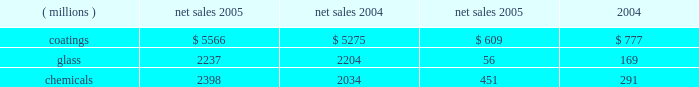Management 2019s discussion and analysis action antitrust legal settlement .
Net income for 2005 and 2004 included an aftertax charge of $ 13 million , or 8 cents a share , and $ 19 million , or 11 cents a share , respectively , to reflect the net increase in the current value of the company 2019s obligation under the ppg settlement arrangement relating to asbestos claims .
Results of business segments net sales operating income ( millions ) 2005 2004 2005 2004 .
Coatings sales increased $ 291 million or 5% ( 5 % ) in 2005 .
Sales increased 3% ( 3 % ) due to higher selling prices across all businesses except automotive ; 1% ( 1 % ) due to improved volumes as increases in our aerospace , architectural and original equipment automotive businesses offset volume declines in automotive refinish and industrial coatings ; and 1% ( 1 % ) due to the positive effects of foreign currency translation .
Operating income decreased $ 168 million in 2005 .
The adverse impact of inflation totaled $ 315 million , of which $ 245 million was attributable to higher raw material costs .
Higher year-over-year selling prices increased operating earnings by $ 169 million .
Coatings operating earnings were reduced by the $ 132 million charge for the cost of the marvin legal settlement net of insurance recoveries .
Other factors increasing coatings operating income in 2005 were the increased sales volumes described above , manufacturing efficiencies , formula cost reductions and higher other income .
Glass sales increased $ 33 million or 1% ( 1 % ) in 2005 .
Sales increased 1% ( 1 % ) due to improved volumes as increases in our automotive replacement glass , insurance and services and performance glazings ( flat glass ) businesses offset volume declines in our fiber glass and automotive original equipment glass businesses .
The positive effects of foreign currency translation were largely offset by lower selling prices primarily in our automotive replacement glass and automotive original equipment businesses .
Operating income decreased $ 113 million in 2005 .
The federal glass class action antitrust legal settlement of $ 61 million , the $ 49 million impact of rising natural gas costs and the absence of the $ 19 million gain in 2004 from the sale/ leaseback of precious metal combined to account for a reduction in operating earnings of $ 129 million .
The remaining year-over-year increase in glass operating earnings of $ 16 million resulted primarily from improved manufacturing efficiencies and lower overhead costs exceeding the adverse impact of other inflation .
Our continuing efforts in 2005 to position the fiber glass business for future growth in profitability were adversely impacted by the rise in fourth quarter natural gas prices , slightly lower year-over-year sales , lower equity earnings due to weaker pricing in the asian electronics market , and the absence of the $ 19 million gain which occurred in 2004 stemming from the sale/ leaseback of precious metals .
Despite high energy costs , we expect fiber glass earnings to improve in 2006 because of price strengthening in the asian electronics market , which began to occur in the fourth quarter of 2005 , increased cost reduction initiatives and the positive impact resulting from the start up of our new joint venture in china .
This joint venture will produce high labor content fiber glass reinforcement products and take advantage of lower labor costs , allowing us to refocus our u.s .
Production capacity on higher margin direct process products .
The 2005 operating earnings of our north american automotive oem glass business declined by $ 30 million compared with 2004 .
Significant structural changes continue to occur in the north american automotive industry , including the loss of u.s .
Market share by general motors and ford .
This has created a very challenging and competitive environment for all suppliers to the domestic oems , including our business .
About half of the decline in earnings resulted from the impact of rising natural gas costs , particularly in the fourth quarter , combined with the traditional adverse impact of year-over-year sales price reductions producing a decline in earnings that exceeded our successful efforts to reduce manufacturing costs .
The other half of the 2005 decline was due to lower sales volumes and mix and higher new program launch costs .
The challenging competitive environment and high energy prices will continue in 2006 .
Our business is working in 2006 to improve its performance through increased manufacturing efficiencies , structural cost reduction initiatives , focusing on profitable growth opportunities and improving our sales mix .
Chemicals sales increased $ 364 million or 18% ( 18 % ) in 2005 .
Sales increased 21% ( 21 % ) due to higher selling prices , primarily for chlor-alkali products , and 1% ( 1 % ) due to the combination of an acquisition in our optical products business and the positive effects of foreign currency translation .
Total volumes declined 4% ( 4 % ) as volume increases in optical products were more than offset by volume declines in chlor-alkali and fine chemicals .
Volume in chlor-alkali products and silicas were adversely impacted in the third and fourth quarters by the hurricanes .
Operating income increased $ 160 million in 2005 .
The primary factor increasing operating income was the record high selling prices in chlor-alkali .
Factors decreasing operating income were higher inflation , including $ 136 million due to increased energy and ethylene costs ; $ 34 million of direct costs related to the impact of the hurricanes ; $ 27 million due to the asset impairment charge related to our fine chemicals business ; lower sales volumes ; higher manufacturing costs and increased environmental expenses .
The increase in chemicals operating earnings occurred primarily through the first eight months of 2005 .
The hurricanes hit in september impacting volumes and costs in september through november and contributing to the rise in natural gas prices which lowered fourth quarter chemicals earnings by $ 58 million , almost 57% ( 57 % ) of the full year impact of higher natural gas prices .
The damage caused by hurricane rita resulted in the shutdown of our lake charles , la chemical plant for a total of eight days in september and an additional five 18 2005 ppg annual report and form 10-k .
What is the operating income percentage for 2005 in the glass segment? 
Computations: (56 / 2237)
Answer: 0.02503. 